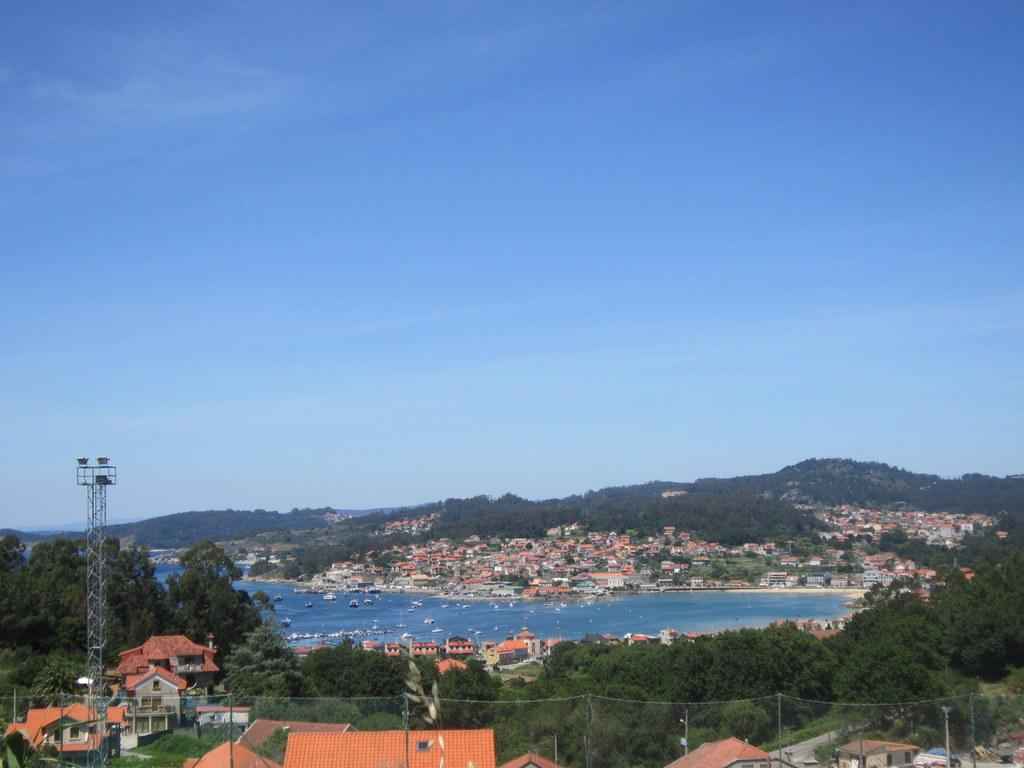What type of structures can be seen in the image? There are many buildings in the image. What natural elements are present in the image? There are trees and a river in the image. What man-made object can be seen in the image? There is a pole in the image. What recreational object is visible in the image? There is a net in the image. What is the color of the sky in the image? The sky is pale blue in the image. What type of fuel is being used by the part in the image? There is no part or fuel present in the image. How many cents are visible in the image? There are no cents present in the image. 